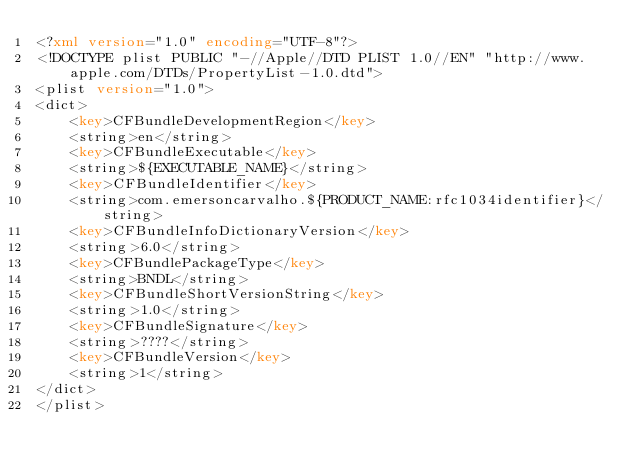Convert code to text. <code><loc_0><loc_0><loc_500><loc_500><_XML_><?xml version="1.0" encoding="UTF-8"?>
<!DOCTYPE plist PUBLIC "-//Apple//DTD PLIST 1.0//EN" "http://www.apple.com/DTDs/PropertyList-1.0.dtd">
<plist version="1.0">
<dict>
	<key>CFBundleDevelopmentRegion</key>
	<string>en</string>
	<key>CFBundleExecutable</key>
	<string>${EXECUTABLE_NAME}</string>
	<key>CFBundleIdentifier</key>
	<string>com.emersoncarvalho.${PRODUCT_NAME:rfc1034identifier}</string>
	<key>CFBundleInfoDictionaryVersion</key>
	<string>6.0</string>
	<key>CFBundlePackageType</key>
	<string>BNDL</string>
	<key>CFBundleShortVersionString</key>
	<string>1.0</string>
	<key>CFBundleSignature</key>
	<string>????</string>
	<key>CFBundleVersion</key>
	<string>1</string>
</dict>
</plist>
</code> 